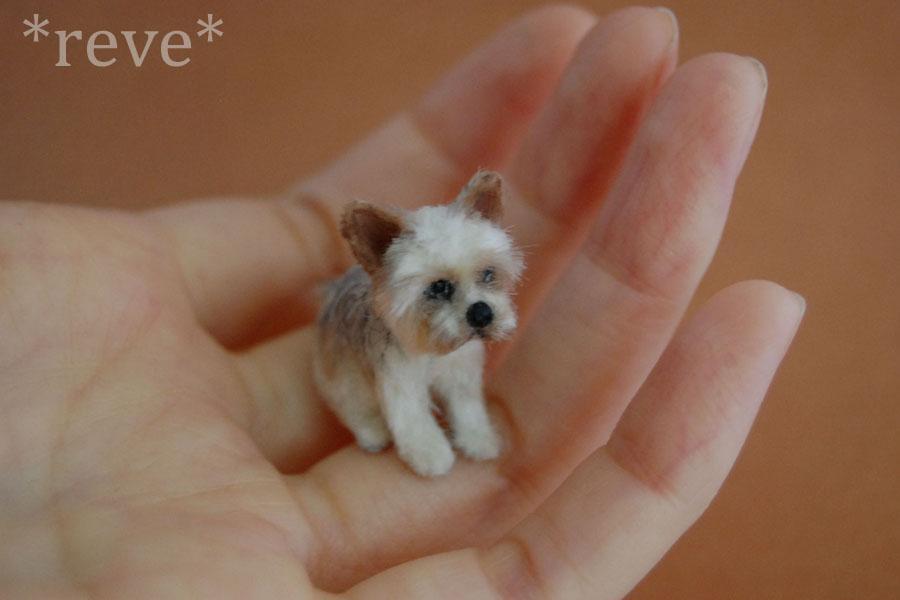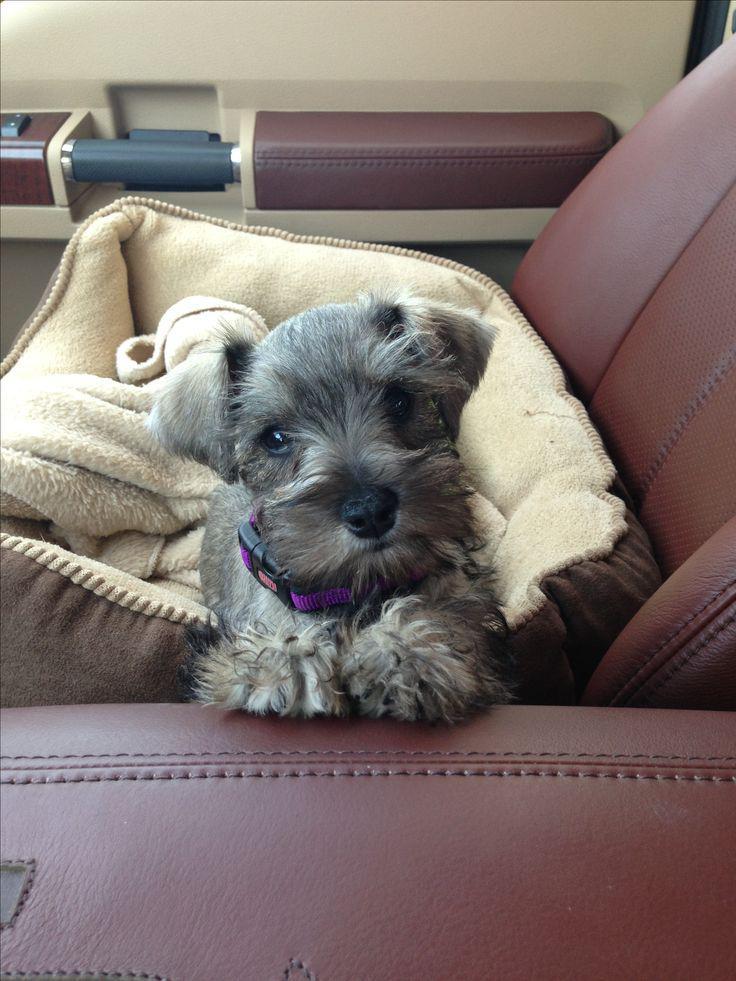The first image is the image on the left, the second image is the image on the right. Evaluate the accuracy of this statement regarding the images: "At least one dog is looking straight ahead.". Is it true? Answer yes or no. Yes. 